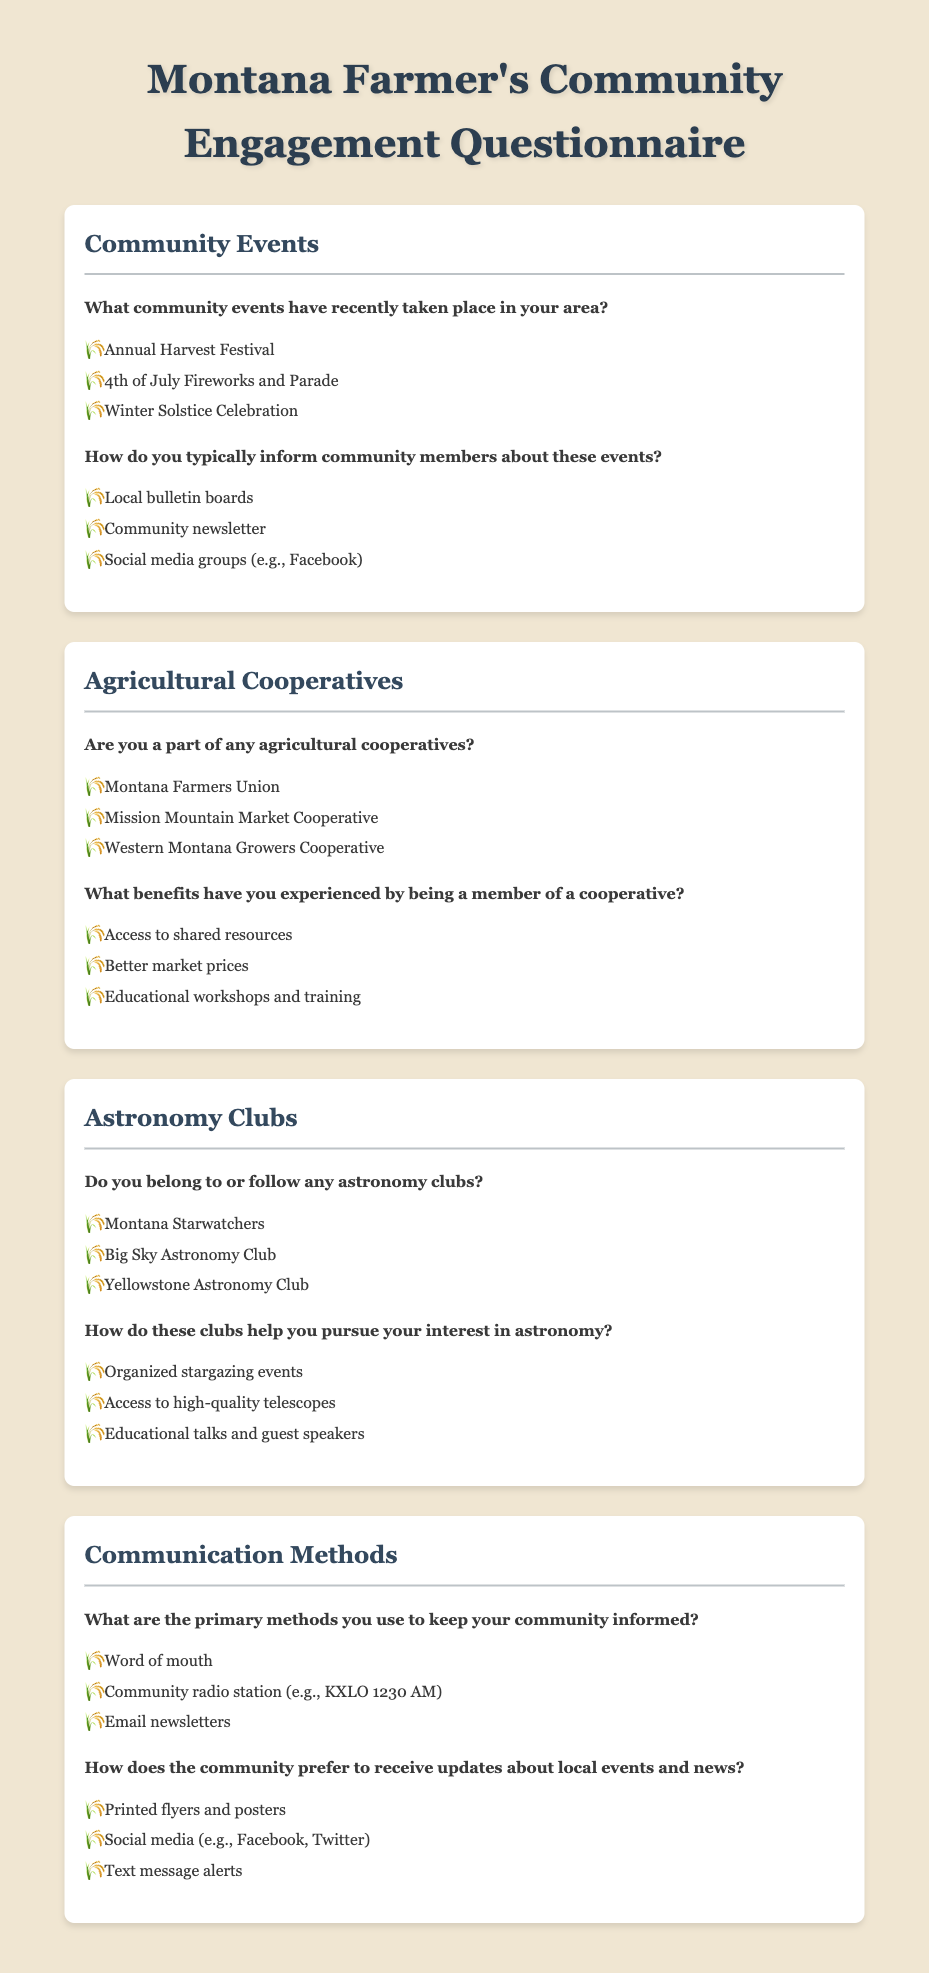What community events have recently taken place? The document lists community events in the section "Community Events."
Answer: Annual Harvest Festival, 4th of July Fireworks and Parade, Winter Solstice Celebration How do you typically inform community members about events? This is explained in the "Community Events" section detailing methods of communication.
Answer: Local bulletin boards, Community newsletter, Social media groups What are some agricultural cooperatives mentioned? The document outlines cooperatives in the "Agricultural Cooperatives" section.
Answer: Montana Farmers Union, Mission Mountain Market Cooperative, Western Montana Growers Cooperative What is a benefit of being a member of a cooperative? The answer is found in the "Agricultural Cooperatives" section that mentions various benefits.
Answer: Access to shared resources, Better market prices, Educational workshops and training Which astronomy clubs are mentioned? This information can be found in the "Astronomy Clubs" section of the document.
Answer: Montana Starwatchers, Big Sky Astronomy Club, Yellowstone Astronomy Club What helps pursue interest in astronomy according to the document? The "Astronomy Clubs" section describes how clubs assist members.
Answer: Organized stargazing events, Access to high-quality telescopes, Educational talks and guest speakers What are the primary methods for keeping the community informed? This is stated in the "Communication Methods" section of the questionnaire.
Answer: Word of mouth, Community radio station, Email newsletters How does the community prefer to receive updates? The preferences are detailed in the "Communication Methods" section of the document.
Answer: Printed flyers and posters, Social media, Text message alerts 